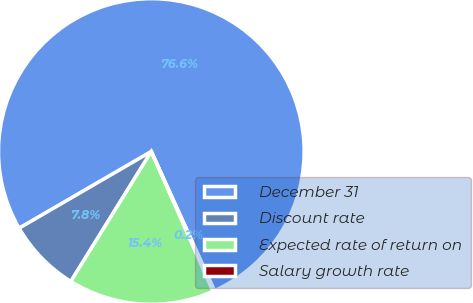<chart> <loc_0><loc_0><loc_500><loc_500><pie_chart><fcel>December 31<fcel>Discount rate<fcel>Expected rate of return on<fcel>Salary growth rate<nl><fcel>76.59%<fcel>7.8%<fcel>15.45%<fcel>0.16%<nl></chart> 